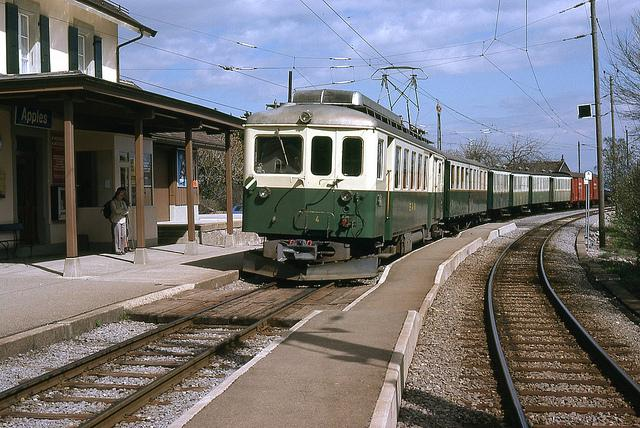What does this train primarily carry? people 